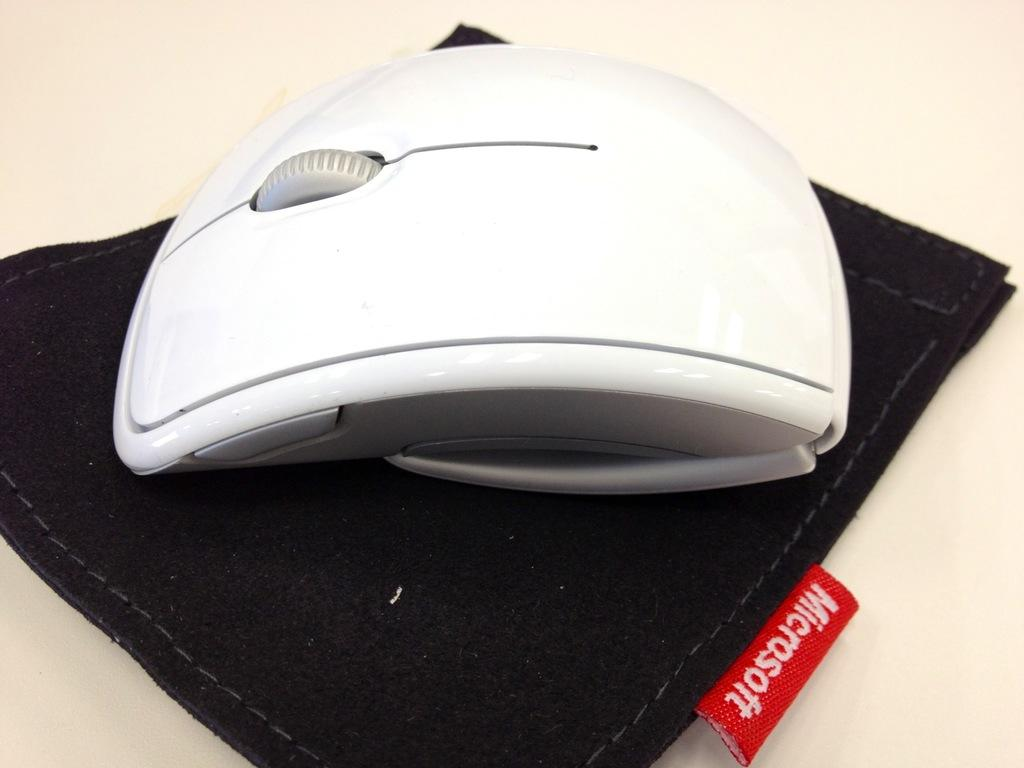What type of computer accessory is in the image? There is a wireless mouse in the image. What is the wireless mouse placed on? The wireless mouse is on a black color cloth. What type of punishment is being depicted in the image? There is no punishment being depicted in the image; it features a wireless mouse on a black color cloth. What level of wealth is represented by the items in the image? The image does not depict any items that can be associated with a specific level of wealth. 